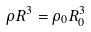<formula> <loc_0><loc_0><loc_500><loc_500>\rho R ^ { 3 } = \rho _ { 0 } R _ { 0 } ^ { 3 }</formula> 